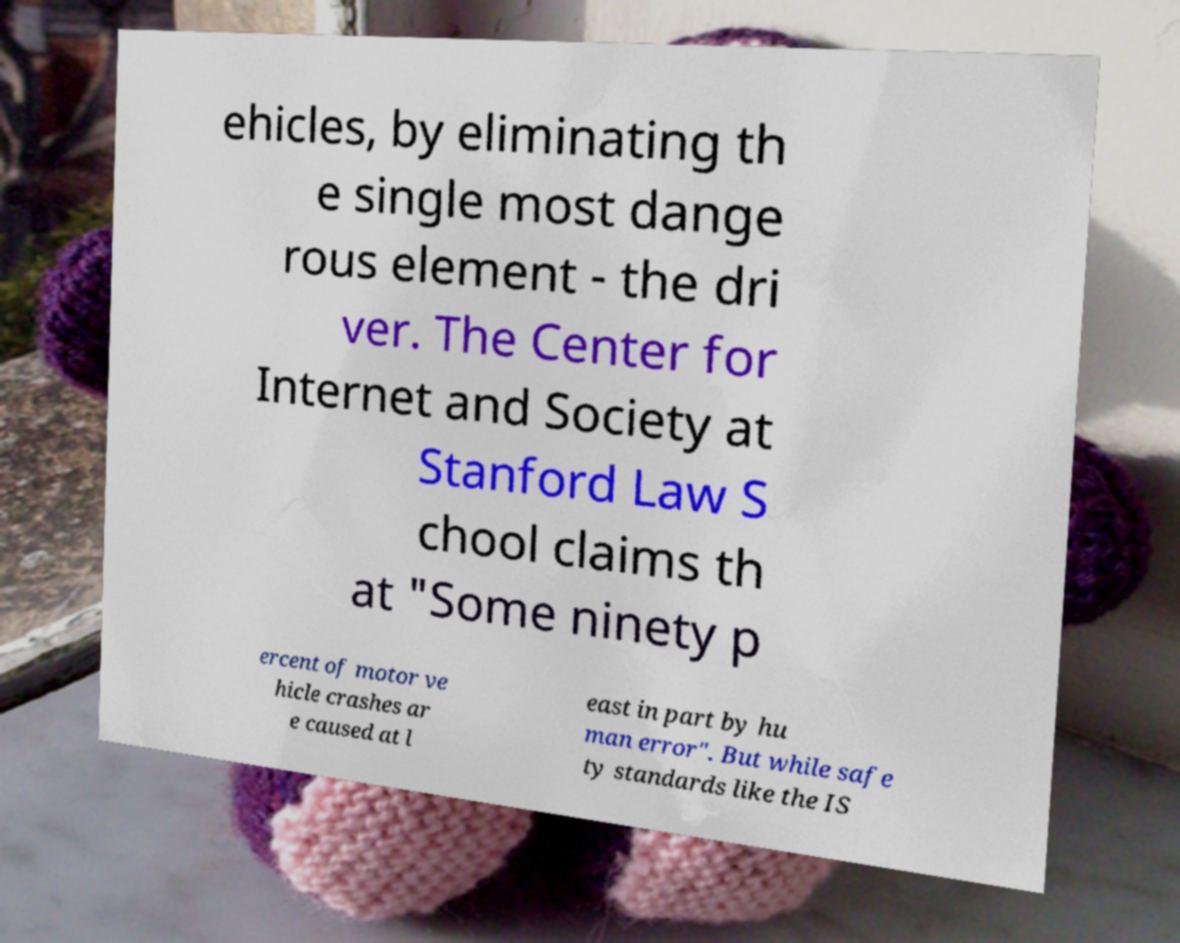For documentation purposes, I need the text within this image transcribed. Could you provide that? ehicles, by eliminating th e single most dange rous element - the dri ver. The Center for Internet and Society at Stanford Law S chool claims th at "Some ninety p ercent of motor ve hicle crashes ar e caused at l east in part by hu man error". But while safe ty standards like the IS 